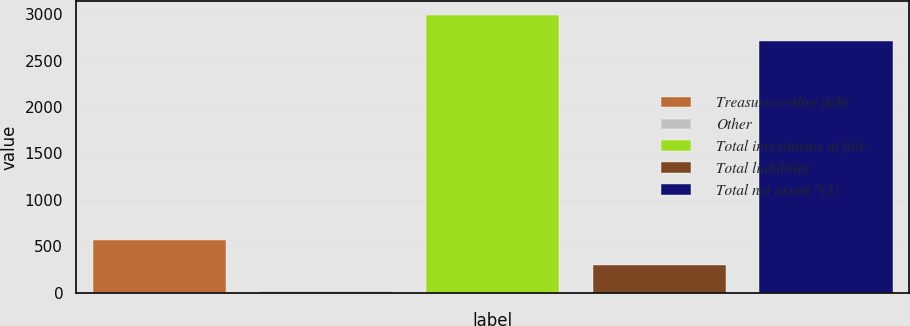<chart> <loc_0><loc_0><loc_500><loc_500><bar_chart><fcel>Treasuries other debt<fcel>Other<fcel>Total investments at fair<fcel>Total liabilities<fcel>Total net assets ^(1)<nl><fcel>572.2<fcel>23<fcel>2988.6<fcel>297.6<fcel>2714<nl></chart> 